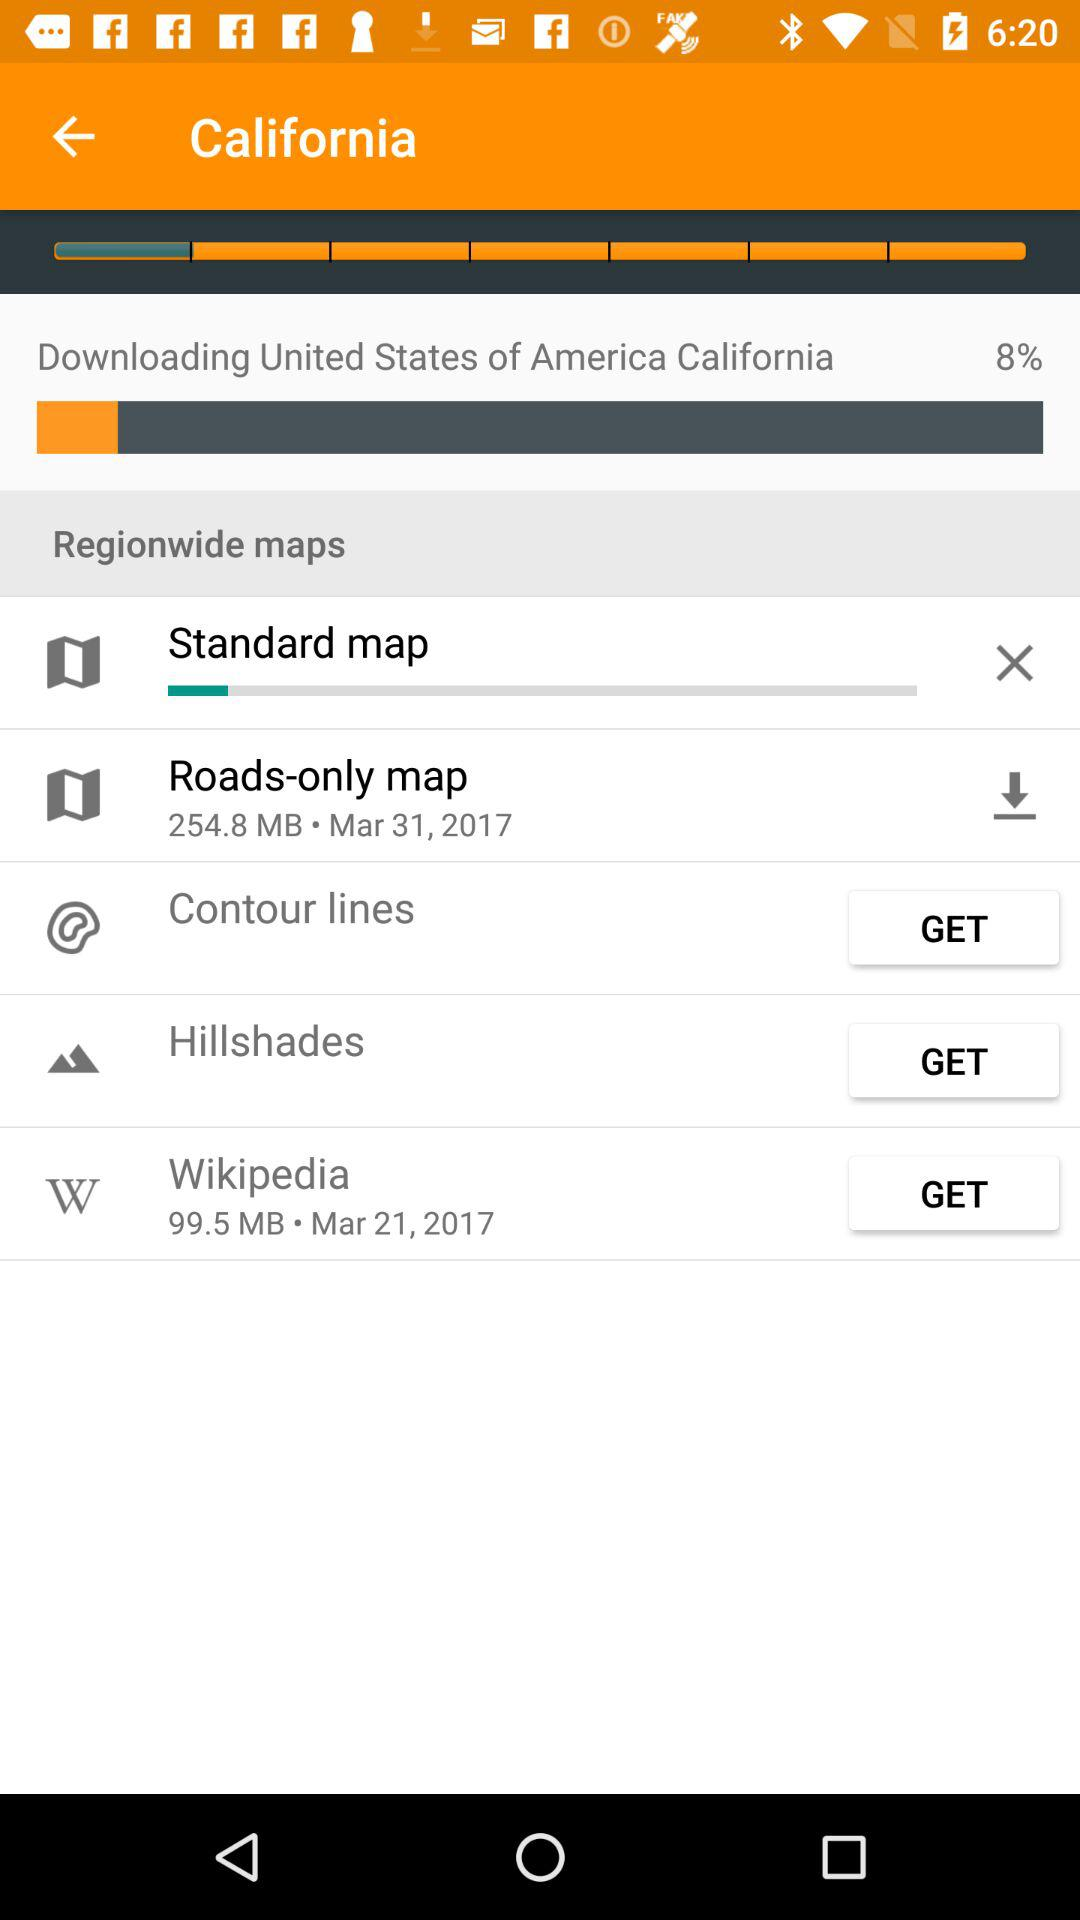What is currently downloading? The document that is currently downloading is "United States of America California". 